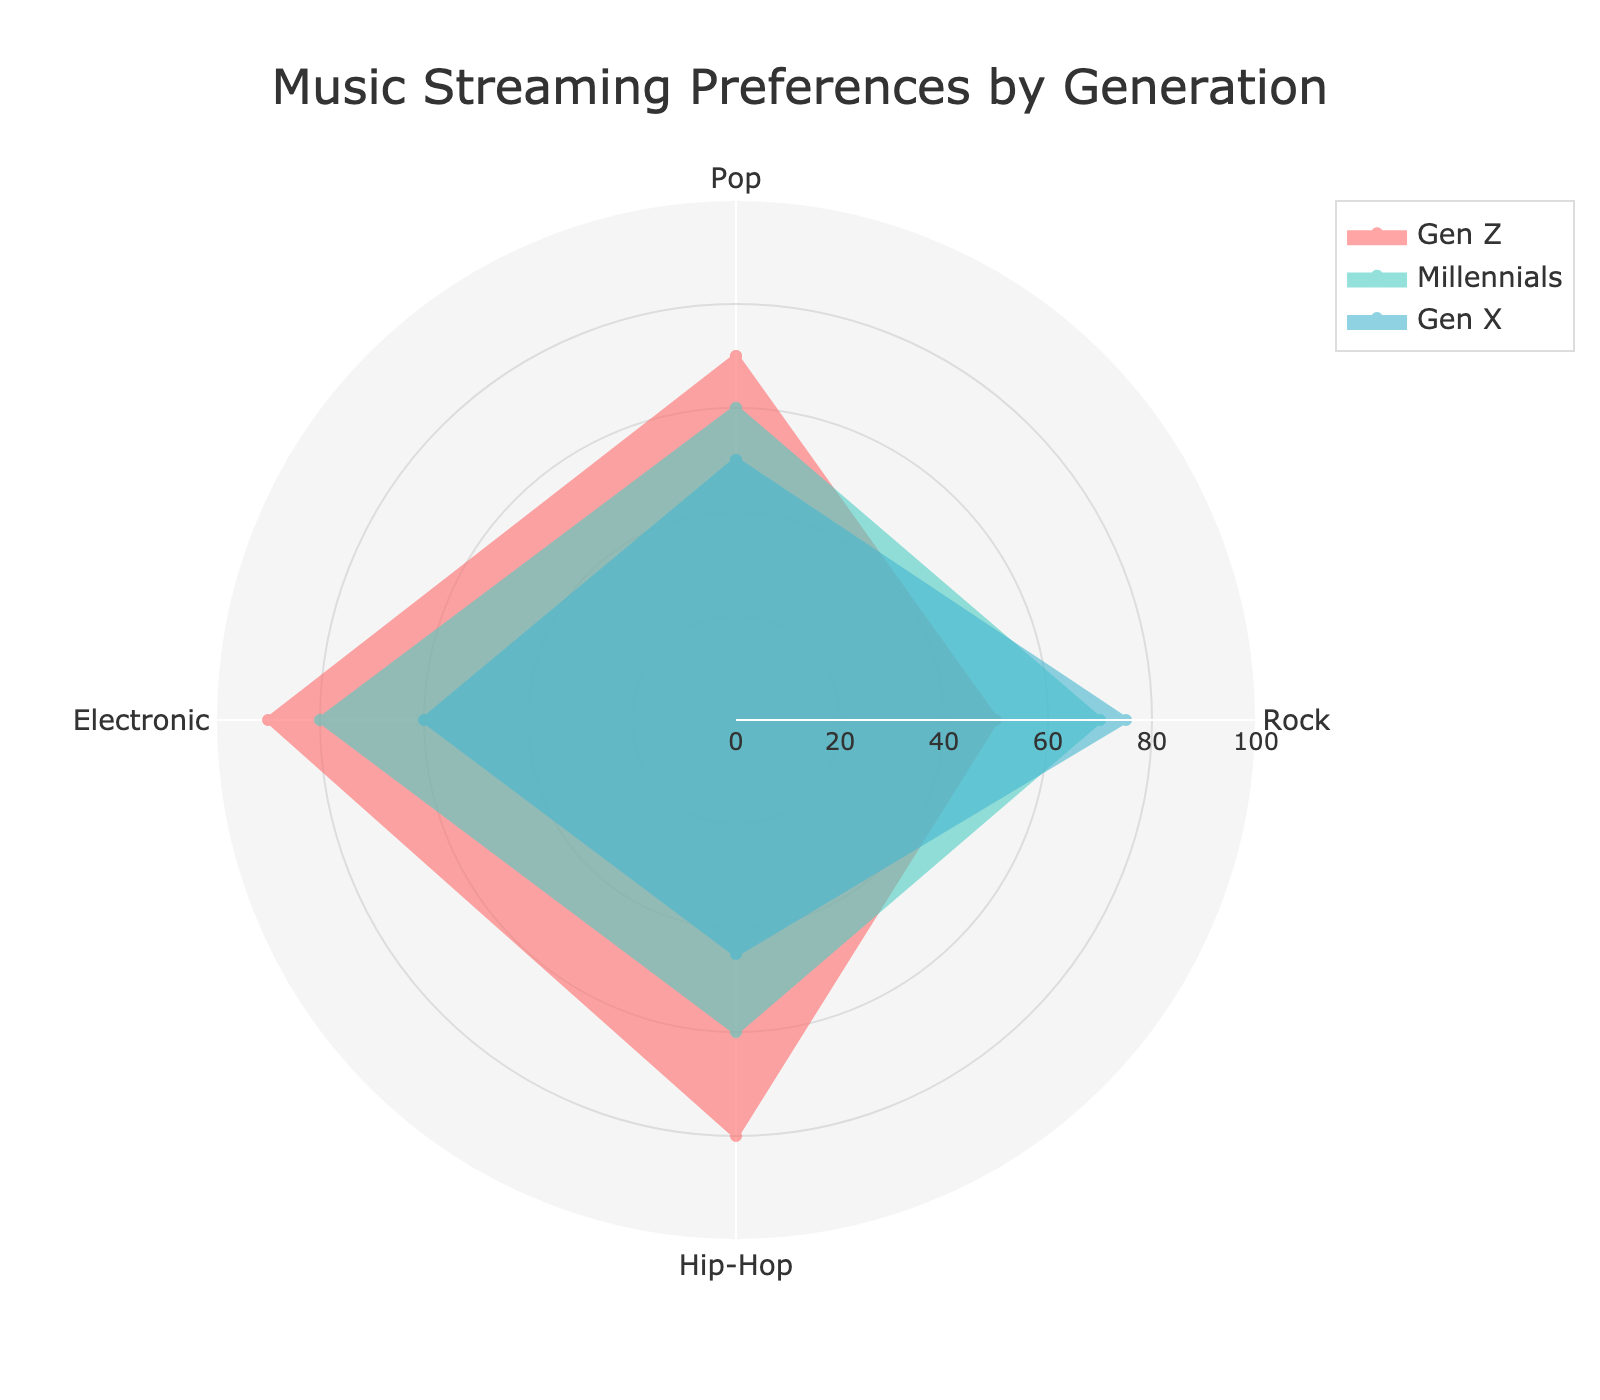What is the title of the radar chart? The title is usually a text element at the top of the figure. By looking at the top of the radar chart, the title reads "Music Streaming Preferences by Generation".
Answer: Music Streaming Preferences by Generation What are the categories (types of music) displayed in the radar chart? Categories are usually the labels around the edges of a radar chart. In this chart, the categories are "Pop", "Rock", "Hip-Hop", and "Electronic".
Answer: Pop, Rock, Hip-Hop, Electronic Which generation shows the highest preference for Electronic music? To answer this, look at which colored line extends furthest in the "Electronic" category on the radar chart. "Gen Z" has the highest value (90) for Electronic music.
Answer: Gen Z What is the difference in preference for Hip-Hop between Gen Z and Gen X? Locate the values for Hip-Hop for both generations on the radar chart. For Gen Z, it's 80, and for Gen X, it's 45. The difference is 80 - 45 = 35.
Answer: 35 Which generation has the lowest average preference across all categories? Calculate the average for each generation by summing their preferences and dividing by the number of categories. Gen Z: (70+50+80+90)/4 = 72.5, Millennials: (60+70+60+80)/4 = 67.5, Gen X: (50+75+45+60)/4 = 57.5. Gen X has the lowest average of 57.5.
Answer: Gen X How does the preference for Rock music compare between Millennials and Boomers? Look at the Rock music values for Millennials (70) and Boomers (70). The values are equal.
Answer: Equal Which generation shows the most balanced preferences across all music types? "Balanced" implies similar values across categories. Calculate the range of values (max - min) for each generation. Gen Z: 90-50=40, Millennials: 80-60=20, Gen X: 75-45=30. Millennials have the smallest range, indicating the most balanced preferences.
Answer: Millennials What is the combined preference for Pop and Hip-Hop by Millennials? Add the values for Pop (60) and Hip-Hop (60) for Millennials. 60 + 60 = 120.
Answer: 120 In which category does Gen X exhibit the highest preference? Locate the maximum value for Gen X across all categories. Their values: Pop (50), Rock (75), Hip-Hop (45), Electronic (60). The highest preference is for Rock (75).
Answer: Rock 